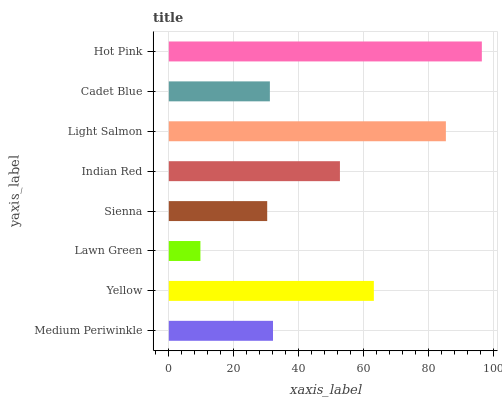Is Lawn Green the minimum?
Answer yes or no. Yes. Is Hot Pink the maximum?
Answer yes or no. Yes. Is Yellow the minimum?
Answer yes or no. No. Is Yellow the maximum?
Answer yes or no. No. Is Yellow greater than Medium Periwinkle?
Answer yes or no. Yes. Is Medium Periwinkle less than Yellow?
Answer yes or no. Yes. Is Medium Periwinkle greater than Yellow?
Answer yes or no. No. Is Yellow less than Medium Periwinkle?
Answer yes or no. No. Is Indian Red the high median?
Answer yes or no. Yes. Is Medium Periwinkle the low median?
Answer yes or no. Yes. Is Light Salmon the high median?
Answer yes or no. No. Is Light Salmon the low median?
Answer yes or no. No. 